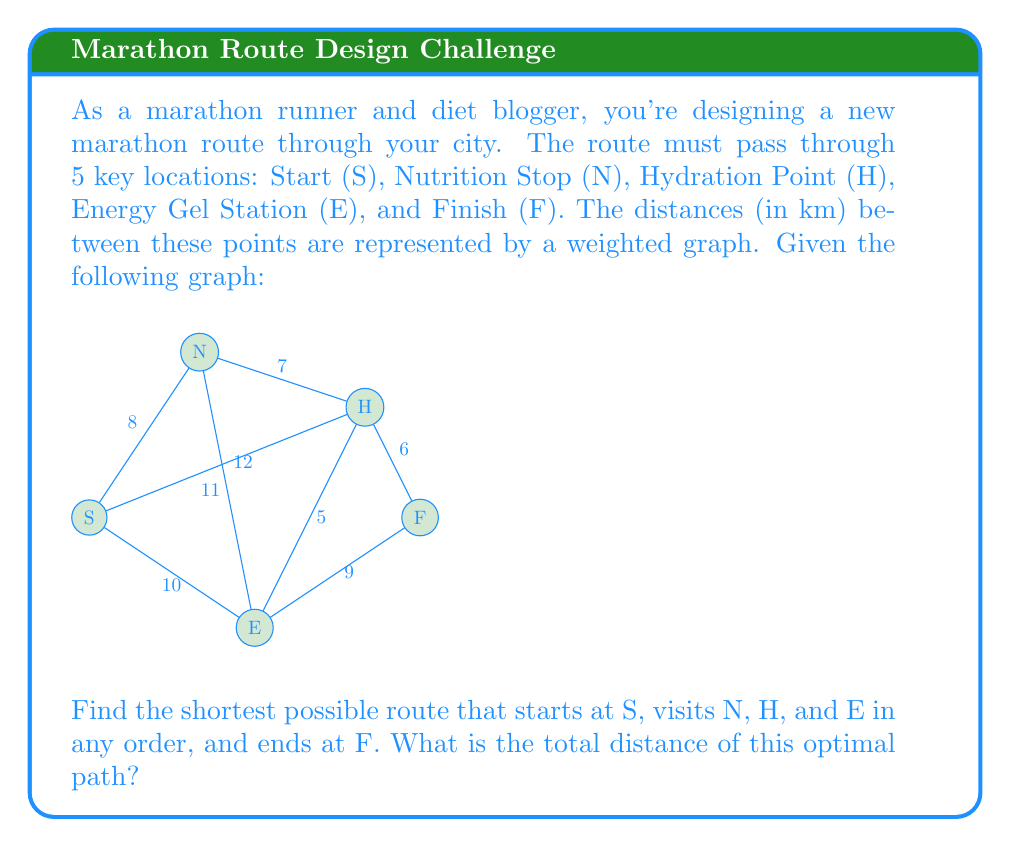Provide a solution to this math problem. To solve this problem, we can use Dijkstra's algorithm to find the shortest path between all pairs of points, and then use dynamic programming to find the optimal order to visit the required points.

Step 1: Use Dijkstra's algorithm to find the shortest distances between all pairs of points.

The resulting distance matrix is:
$$
\begin{array}{c|ccccc}
 & S & N & H & E & F \\
\hline
S & 0 & 8 & 12 & 10 & 18 \\
N & 8 & 0 & 7 & 11 & 13 \\
H & 12 & 7 & 0 & 5 & 6 \\
E & 10 & 11 & 5 & 0 & 9 \\
F & 18 & 13 & 6 & 9 & 0
\end{array}
$$

Step 2: Use dynamic programming to find the optimal path.

Let $dp(mask, v)$ be the shortest distance to visit all points in the mask and end at vertex $v$.

Base case: $dp(\{N, H, E\}, v) = dist(S, v)$ for $v \in \{N, H, E\}$

Recurrence:
$$dp(mask, v) = \min_{u \in mask} \{dp(mask \setminus \{v\}, u) + dist(u, v)\}$$

Final answer: $\min_{v \in \{N, H, E\}} \{dp(\{N, H, E\}, v) + dist(v, F)\}$

Applying this algorithm:

1. $dp(\{N, H, E\}, N) = 8$
2. $dp(\{N, H, E\}, H) = 12$
3. $dp(\{N, H, E\}, E) = 10$
4. $dp(\{H, E\}, N) = \min(8 + 7, 12 + 7, 10 + 11) = 15$ (from H)
5. $dp(\{N, E\}, H) = \min(8 + 7, 12 + 0, 10 + 5) = 15$ (from N)
6. $dp(\{N, H\}, E) = \min(8 + 11, 12 + 5, 10 + 0) = 15$ (from H)
7. $dp(\{E\}, N) = \min(15 + 11, 15 + 7) = 22$ (from H)
8. $dp(\{H\}, N) = \min(15 + 7, 15 + 7) = 22$ (from H or E)
9. $dp(\{N\}, H) = \min(15 + 0, 22 + 0) = 15$ (from E)
10. $dp(\{\}, N) = \min(22 + 0, 15 + 7) = 22$ (from H)

The optimal path ends at N, so the final distance is:
$$22 + dist(N, F) = 22 + 13 = 35$$

The optimal path is: S → E → H → N → F
Answer: The shortest possible route has a total distance of 35 km. 